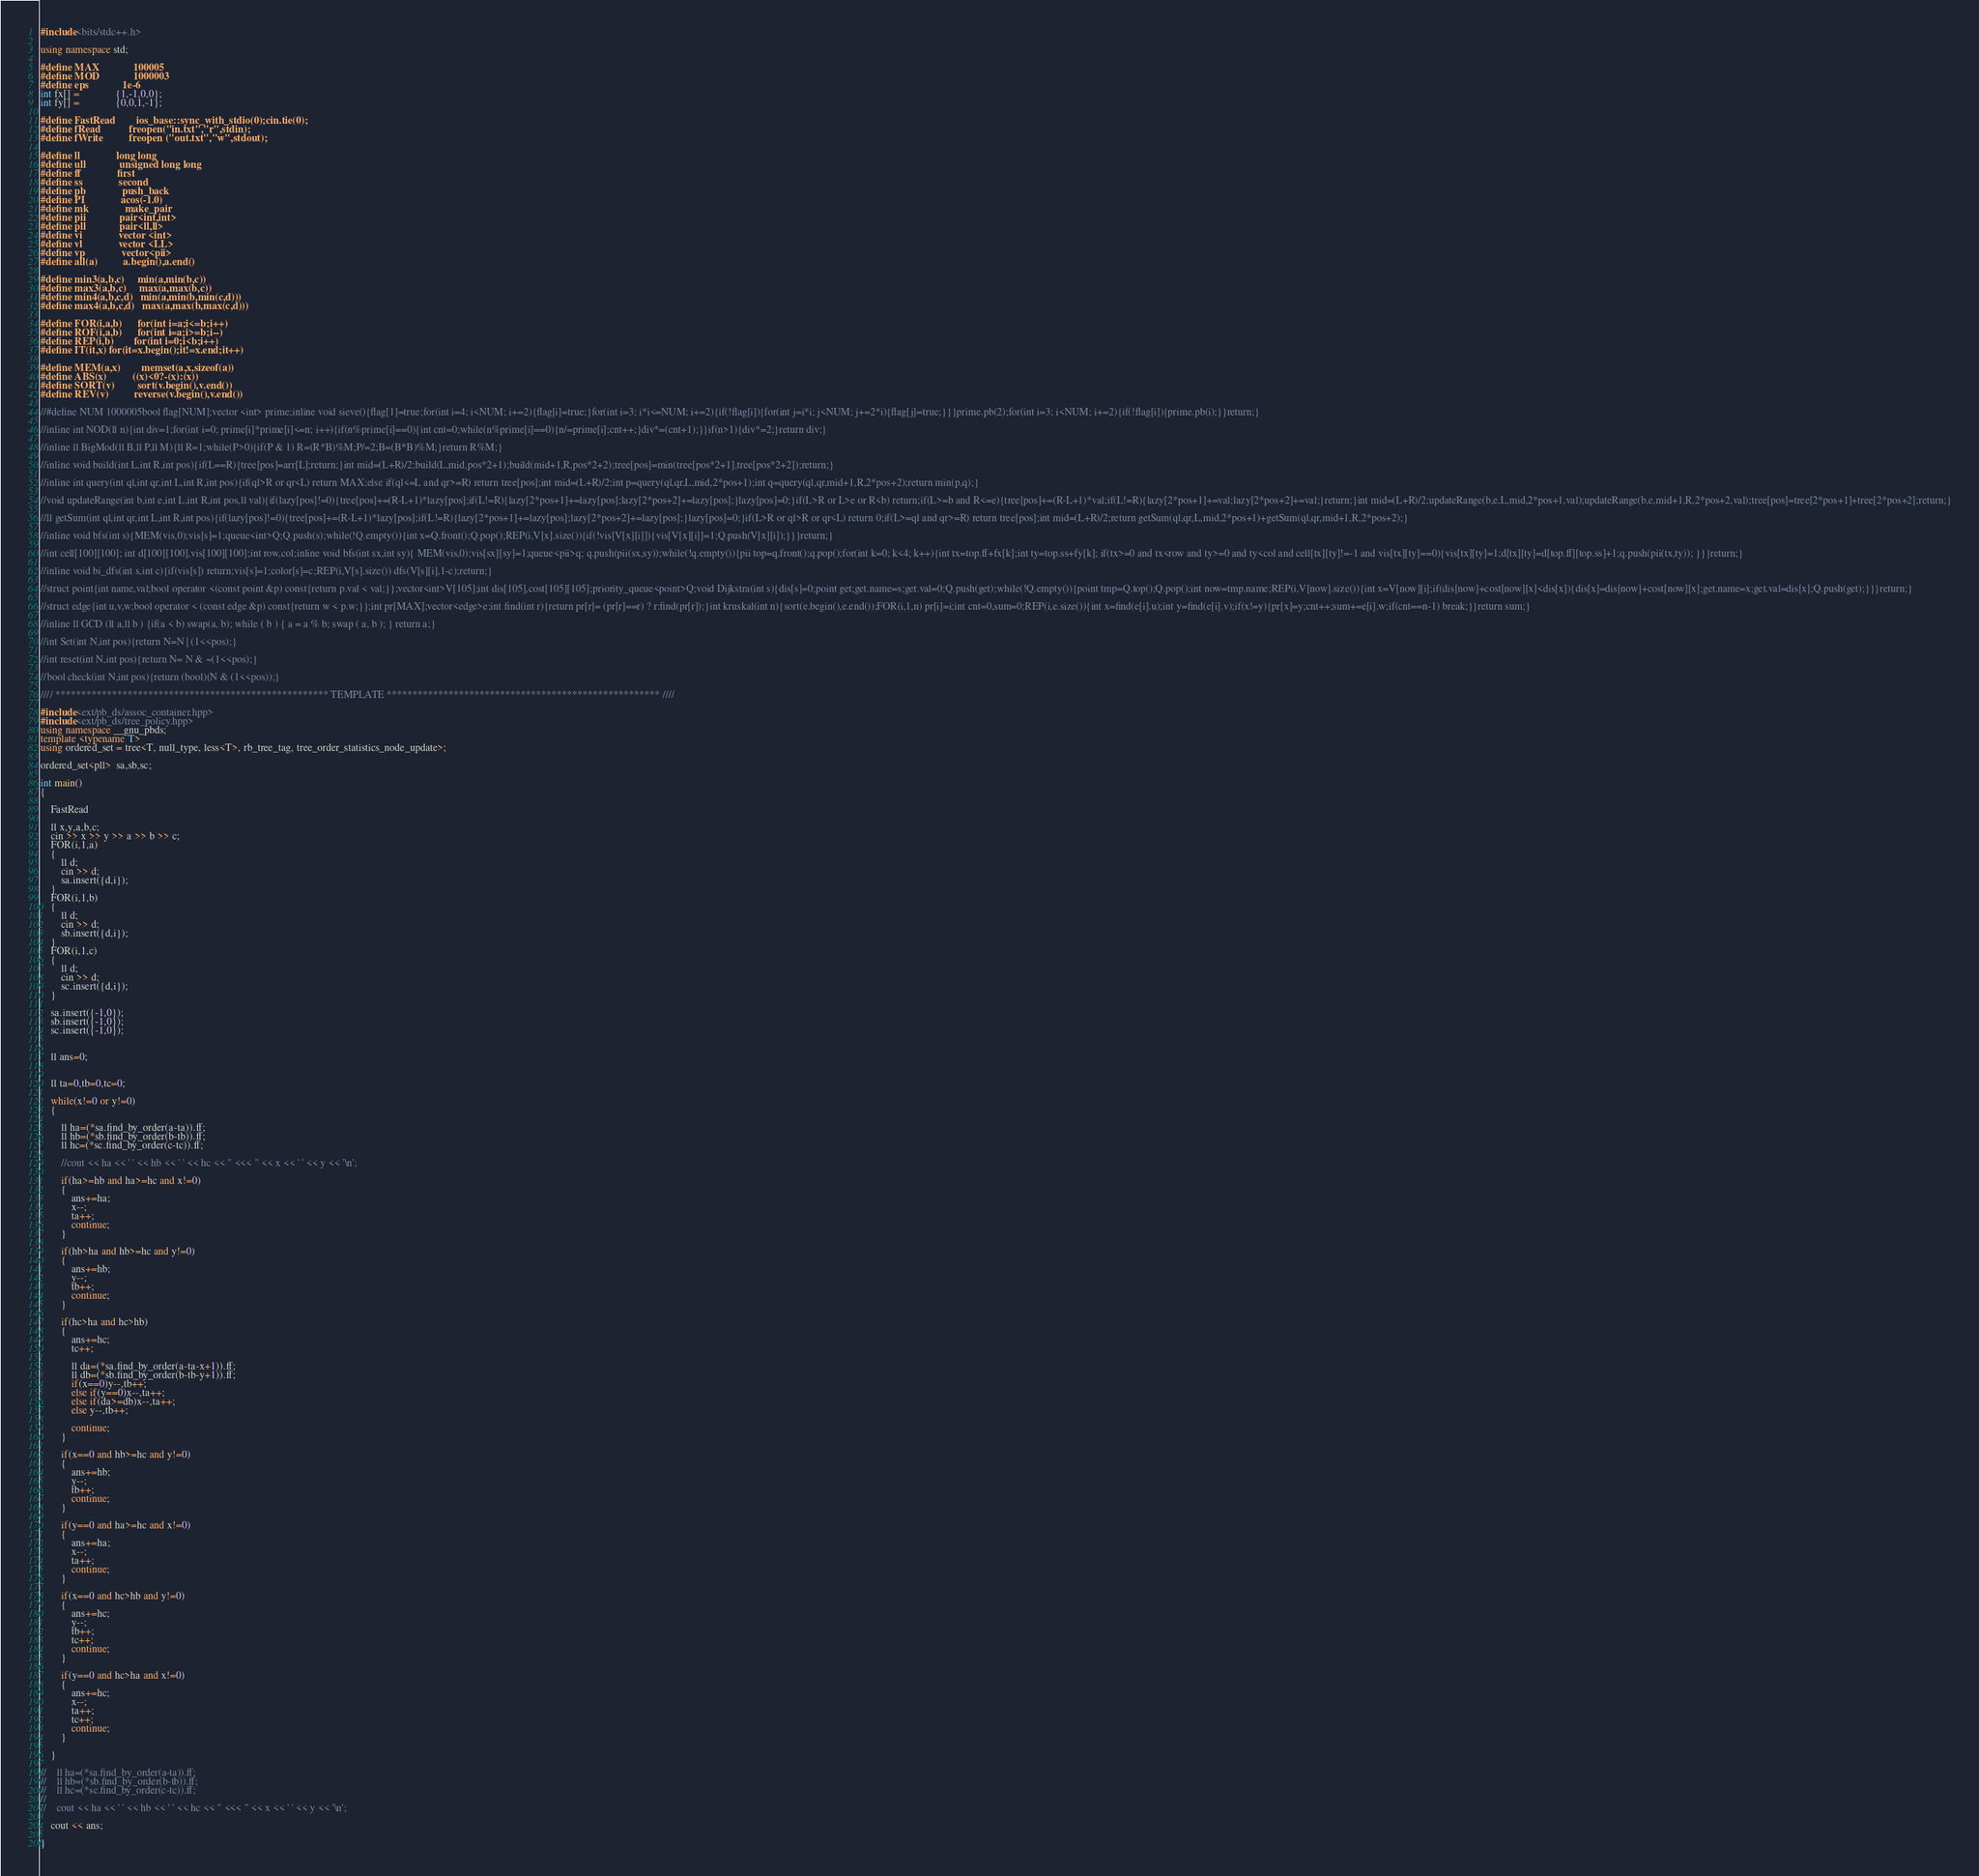<code> <loc_0><loc_0><loc_500><loc_500><_C++_>#include<bits/stdc++.h>

using namespace std;

#define MAX             100005
#define MOD             1000003
#define eps             1e-6
int fx[] =              {1,-1,0,0};
int fy[] =              {0,0,1,-1};

#define FastRead        ios_base::sync_with_stdio(0);cin.tie(0);
#define fRead           freopen("in.txt","r",stdin);
#define fWrite          freopen ("out.txt","w",stdout);

#define ll              long long
#define ull             unsigned long long
#define ff              first
#define ss              second
#define pb              push_back
#define PI              acos(-1.0)
#define mk              make_pair
#define pii             pair<int,int>
#define pll             pair<ll,ll>
#define vi              vector <int>
#define vl              vector <LL>
#define vp              vector<pii>
#define all(a)          a.begin(),a.end()

#define min3(a,b,c)     min(a,min(b,c))
#define max3(a,b,c)     max(a,max(b,c))
#define min4(a,b,c,d)   min(a,min(b,min(c,d)))
#define max4(a,b,c,d)   max(a,max(b,max(c,d)))

#define FOR(i,a,b)      for(int i=a;i<=b;i++)
#define ROF(i,a,b)      for(int i=a;i>=b;i--)
#define REP(i,b)        for(int i=0;i<b;i++)
#define IT(it,x)	for(it=x.begin();it!=x.end;it++)

#define MEM(a,x)        memset(a,x,sizeof(a))
#define ABS(x)          ((x)<0?-(x):(x))
#define SORT(v)         sort(v.begin(),v.end())
#define REV(v)          reverse(v.begin(),v.end())

//#define NUM 1000005bool flag[NUM];vector <int> prime;inline void sieve(){flag[1]=true;for(int i=4; i<NUM; i+=2){flag[i]=true;}for(int i=3; i*i<=NUM; i+=2){if(!flag[i]){for(int j=i*i; j<NUM; j+=2*i){flag[j]=true;}}}prime.pb(2);for(int i=3; i<NUM; i+=2){if(!flag[i]){prime.pb(i);}}return;}

//inline int NOD(ll n){int div=1;for(int i=0; prime[i]*prime[i]<=n; i++){if(n%prime[i]==0){int cnt=0;while(n%prime[i]==0){n/=prime[i];cnt++;}div*=(cnt+1);}}if(n>1){div*=2;}return div;}

//inline ll BigMod(ll B,ll P,ll M){ll R=1;while(P>0){if(P & 1) R=(R*B)%M;P/=2;B=(B*B)%M;}return R%M;}

//inline void build(int L,int R,int pos){if(L==R){tree[pos]=arr[L];return;}int mid=(L+R)/2;build(L,mid,pos*2+1);build(mid+1,R,pos*2+2);tree[pos]=min(tree[pos*2+1],tree[pos*2+2]);return;}

//inline int query(int ql,int qr,int L,int R,int pos){if(ql>R or qr<L) return MAX;else if(ql<=L and qr>=R) return tree[pos];int mid=(L+R)/2;int p=query(ql,qr,L,mid,2*pos+1);int q=query(ql,qr,mid+1,R,2*pos+2);return min(p,q);}

//void updateRange(int b,int e,int L,int R,int pos,ll val){if(lazy[pos]!=0){tree[pos]+=(R-L+1)*lazy[pos];if(L!=R){lazy[2*pos+1]+=lazy[pos];lazy[2*pos+2]+=lazy[pos];}lazy[pos]=0;}if(L>R or L>e or R<b) return;if(L>=b and R<=e){tree[pos]+=(R-L+1)*val;if(L!=R){lazy[2*pos+1]+=val;lazy[2*pos+2]+=val;}return;}int mid=(L+R)/2;updateRange(b,e,L,mid,2*pos+1,val);updateRange(b,e,mid+1,R,2*pos+2,val);tree[pos]=tree[2*pos+1]+tree[2*pos+2];return;}

//ll getSum(int ql,int qr,int L,int R,int pos){if(lazy[pos]!=0){tree[pos]+=(R-L+1)*lazy[pos];if(L!=R){lazy[2*pos+1]+=lazy[pos];lazy[2*pos+2]+=lazy[pos];}lazy[pos]=0;}if(L>R or ql>R or qr<L) return 0;if(L>=ql and qr>=R) return tree[pos];int mid=(L+R)/2;return getSum(ql,qr,L,mid,2*pos+1)+getSum(ql,qr,mid+1,R,2*pos+2);}

//inline void bfs(int s){MEM(vis,0);vis[s]=1;queue<int>Q;Q.push(s);while(!Q.empty()){int x=Q.front();Q.pop();REP(i,V[x].size()){if(!vis[V[x][i]]){vis[V[x][i]]=1;Q.push(V[x][i]);}}}return;}

//int cell[100][100]; int d[100][100],vis[100][100];int row,col;inline void bfs(int sx,int sy){ MEM(vis,0);vis[sx][sy]=1;queue<pii>q; q.push(pii(sx,sy));while(!q.empty()){pii top=q.front();q.pop();for(int k=0; k<4; k++){int tx=top.ff+fx[k];int ty=top.ss+fy[k]; if(tx>=0 and tx<row and ty>=0 and ty<col and cell[tx][ty]!=-1 and vis[tx][ty]==0){vis[tx][ty]=1;d[tx][ty]=d[top.ff][top.ss]+1;q.push(pii(tx,ty)); }}}return;}

//inline void bi_dfs(int s,int c){if(vis[s]) return;vis[s]=1;color[s]=c;REP(i,V[s].size()) dfs(V[s][i],1-c);return;}

//struct point{int name,val;bool operator <(const point &p) const{return p.val < val;}};vector<int>V[105];int dis[105],cost[105][105];priority_queue<point>Q;void Dijkstra(int s){dis[s]=0;point get;get.name=s;get.val=0;Q.push(get);while(!Q.empty()){point tmp=Q.top();Q.pop();int now=tmp.name;REP(i,V[now].size()){int x=V[now][i];if(dis[now]+cost[now][x]<dis[x]){dis[x]=dis[now]+cost[now][x];get.name=x;get.val=dis[x];Q.push(get);}}}return;}

//struct edge{int u,v,w;bool operator < (const edge &p) const{return w < p.w;}};int pr[MAX];vector<edge>e;int find(int r){return pr[r]= (pr[r]==r) ? r:find(pr[r]);}int kruskal(int n){sort(e.begin(),e.end());FOR(i,1,n) pr[i]=i;int cnt=0,sum=0;REP(i,e.size()){int x=find(e[i].u);int y=find(e[i].v);if(x!=y){pr[x]=y;cnt++;sum+=e[i].w;if(cnt==n-1) break;}}return sum;}

//inline ll GCD (ll a,ll b ) {if(a < b) swap(a, b); while ( b ) { a = a % b; swap ( a, b ); } return a;}

//int Set(int N,int pos){return N=N | (1<<pos);}

//int reset(int N,int pos){return N= N & ~(1<<pos);}

//bool check(int N,int pos){return (bool)(N & (1<<pos));}

//// ***************************************************** TEMPLATE ***************************************************** ////

#include<ext/pb_ds/assoc_container.hpp>
#include<ext/pb_ds/tree_policy.hpp>
using namespace __gnu_pbds;
template <typename T>
using ordered_set = tree<T, null_type, less<T>, rb_tree_tag, tree_order_statistics_node_update>;

ordered_set<pll>  sa,sb,sc;

int main()
{

    FastRead

    ll x,y,a,b,c;
    cin >> x >> y >> a >> b >> c;
    FOR(i,1,a)
    {
        ll d;
        cin >> d;
        sa.insert({d,i});
    }
    FOR(i,1,b)
    {
        ll d;
        cin >> d;
        sb.insert({d,i});
    }
    FOR(i,1,c)
    {
        ll d;
        cin >> d;
        sc.insert({d,i});
    }

    sa.insert({-1,0});
    sb.insert({-1,0});
    sc.insert({-1,0});


    ll ans=0;


    ll ta=0,tb=0,tc=0;

    while(x!=0 or y!=0)
    {

        ll ha=(*sa.find_by_order(a-ta)).ff;
        ll hb=(*sb.find_by_order(b-tb)).ff;
        ll hc=(*sc.find_by_order(c-tc)).ff;

        //cout << ha << ' ' << hb << ' ' << hc << " <<< " << x << ' ' << y << '\n';

        if(ha>=hb and ha>=hc and x!=0)
        {
            ans+=ha;
            x--;
            ta++;
            continue;
        }

        if(hb>ha and hb>=hc and y!=0)
        {
            ans+=hb;
            y--;
            tb++;
            continue;
        }

        if(hc>ha and hc>hb)
        {
            ans+=hc;
            tc++;

            ll da=(*sa.find_by_order(a-ta-x+1)).ff;
            ll db=(*sb.find_by_order(b-tb-y+1)).ff;
            if(x==0)y--,tb++;
            else if(y==0)x--,ta++;
            else if(da>=db)x--,ta++;
            else y--,tb++;

            continue;
        }

        if(x==0 and hb>=hc and y!=0)
        {
            ans+=hb;
            y--;
            tb++;
            continue;
        }

        if(y==0 and ha>=hc and x!=0)
        {
            ans+=ha;
            x--;
            ta++;
            continue;
        }

        if(x==0 and hc>hb and y!=0)
        {
            ans+=hc;
            y--;
          	tb++;
            tc++;
            continue;
        }

        if(y==0 and hc>ha and x!=0)
        {
            ans+=hc;
            x--;
          	ta++;
            tc++;
            continue;
        }

    }

//    ll ha=(*sa.find_by_order(a-ta)).ff;
//    ll hb=(*sb.find_by_order(b-tb)).ff;
//    ll hc=(*sc.find_by_order(c-tc)).ff;
//
//    cout << ha << ' ' << hb << ' ' << hc << " <<< " << x << ' ' << y << '\n';

    cout << ans;

}
</code> 